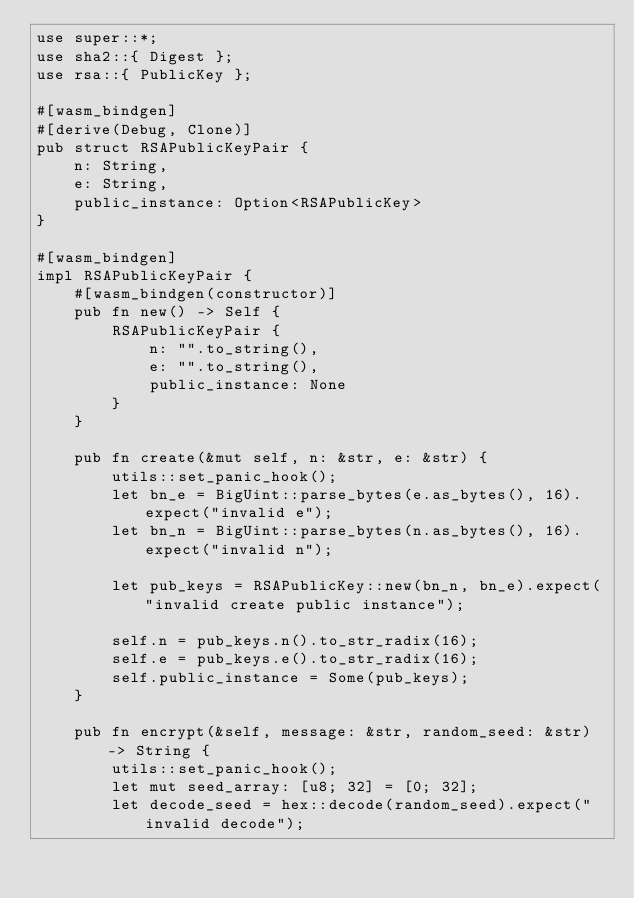<code> <loc_0><loc_0><loc_500><loc_500><_Rust_>use super::*;
use sha2::{ Digest };
use rsa::{ PublicKey };

#[wasm_bindgen]
#[derive(Debug, Clone)]
pub struct RSAPublicKeyPair {
    n: String,
    e: String,
    public_instance: Option<RSAPublicKey>
}

#[wasm_bindgen]
impl RSAPublicKeyPair {
    #[wasm_bindgen(constructor)]
    pub fn new() -> Self {
        RSAPublicKeyPair {
            n: "".to_string(),
            e: "".to_string(),
            public_instance: None
        }
    }

    pub fn create(&mut self, n: &str, e: &str) {
        utils::set_panic_hook();
        let bn_e = BigUint::parse_bytes(e.as_bytes(), 16).expect("invalid e");
        let bn_n = BigUint::parse_bytes(n.as_bytes(), 16).expect("invalid n");

        let pub_keys = RSAPublicKey::new(bn_n, bn_e).expect("invalid create public instance");

        self.n = pub_keys.n().to_str_radix(16);
        self.e = pub_keys.e().to_str_radix(16);
        self.public_instance = Some(pub_keys);
    }

    pub fn encrypt(&self, message: &str, random_seed: &str) -> String {
        utils::set_panic_hook();
        let mut seed_array: [u8; 32] = [0; 32];
        let decode_seed = hex::decode(random_seed).expect("invalid decode");</code> 